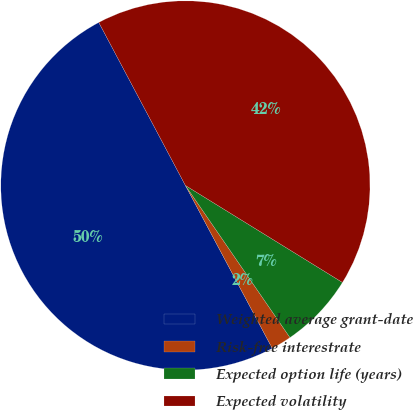<chart> <loc_0><loc_0><loc_500><loc_500><pie_chart><fcel>Weighted average grant-date<fcel>Risk-free interestrate<fcel>Expected option life (years)<fcel>Expected volatility<nl><fcel>50.02%<fcel>1.79%<fcel>6.61%<fcel>41.58%<nl></chart> 